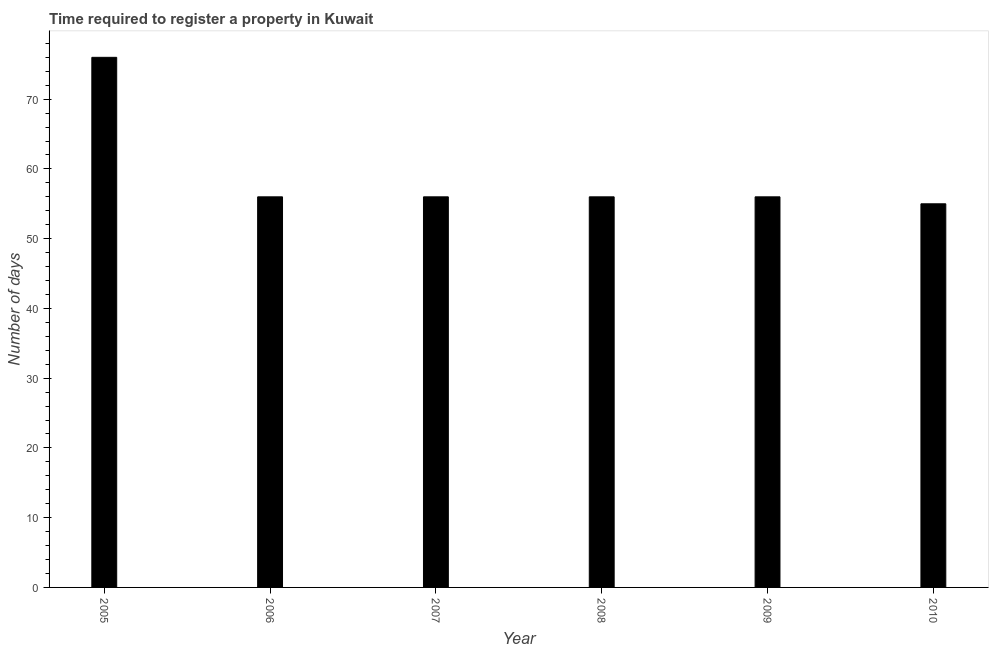Does the graph contain any zero values?
Offer a very short reply. No. What is the title of the graph?
Your answer should be compact. Time required to register a property in Kuwait. What is the label or title of the Y-axis?
Your answer should be compact. Number of days. Across all years, what is the minimum number of days required to register property?
Provide a succinct answer. 55. What is the sum of the number of days required to register property?
Make the answer very short. 355. What is the median number of days required to register property?
Provide a short and direct response. 56. In how many years, is the number of days required to register property greater than 22 days?
Your answer should be compact. 6. Do a majority of the years between 2007 and 2005 (inclusive) have number of days required to register property greater than 14 days?
Provide a succinct answer. Yes. Is the difference between the number of days required to register property in 2006 and 2008 greater than the difference between any two years?
Ensure brevity in your answer.  No. What is the difference between the highest and the second highest number of days required to register property?
Your answer should be compact. 20. What is the difference between the highest and the lowest number of days required to register property?
Offer a very short reply. 21. In how many years, is the number of days required to register property greater than the average number of days required to register property taken over all years?
Offer a very short reply. 1. How many years are there in the graph?
Keep it short and to the point. 6. What is the Number of days of 2005?
Give a very brief answer. 76. What is the Number of days in 2006?
Your answer should be very brief. 56. What is the Number of days of 2007?
Give a very brief answer. 56. What is the Number of days in 2010?
Offer a terse response. 55. What is the difference between the Number of days in 2006 and 2009?
Your answer should be very brief. 0. What is the difference between the Number of days in 2006 and 2010?
Your answer should be compact. 1. What is the difference between the Number of days in 2007 and 2008?
Your answer should be very brief. 0. What is the difference between the Number of days in 2007 and 2009?
Your answer should be compact. 0. What is the difference between the Number of days in 2007 and 2010?
Make the answer very short. 1. What is the difference between the Number of days in 2008 and 2010?
Your answer should be compact. 1. What is the ratio of the Number of days in 2005 to that in 2006?
Keep it short and to the point. 1.36. What is the ratio of the Number of days in 2005 to that in 2007?
Offer a terse response. 1.36. What is the ratio of the Number of days in 2005 to that in 2008?
Keep it short and to the point. 1.36. What is the ratio of the Number of days in 2005 to that in 2009?
Keep it short and to the point. 1.36. What is the ratio of the Number of days in 2005 to that in 2010?
Make the answer very short. 1.38. What is the ratio of the Number of days in 2006 to that in 2007?
Provide a short and direct response. 1. What is the ratio of the Number of days in 2006 to that in 2009?
Provide a short and direct response. 1. What is the ratio of the Number of days in 2007 to that in 2008?
Ensure brevity in your answer.  1. What is the ratio of the Number of days in 2007 to that in 2010?
Ensure brevity in your answer.  1.02. What is the ratio of the Number of days in 2009 to that in 2010?
Keep it short and to the point. 1.02. 